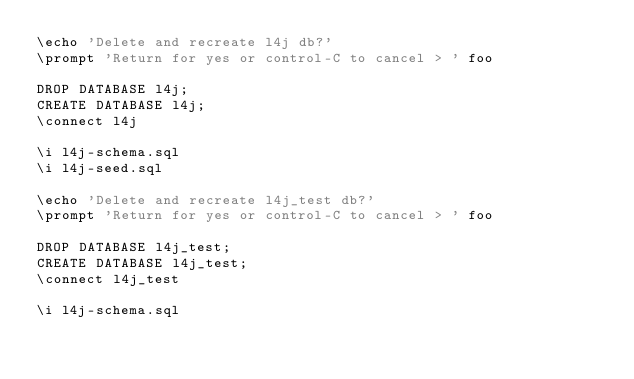Convert code to text. <code><loc_0><loc_0><loc_500><loc_500><_SQL_>\echo 'Delete and recreate l4j db?'
\prompt 'Return for yes or control-C to cancel > ' foo

DROP DATABASE l4j;
CREATE DATABASE l4j;
\connect l4j

\i l4j-schema.sql
\i l4j-seed.sql

\echo 'Delete and recreate l4j_test db?'
\prompt 'Return for yes or control-C to cancel > ' foo

DROP DATABASE l4j_test;
CREATE DATABASE l4j_test;
\connect l4j_test

\i l4j-schema.sql
</code> 